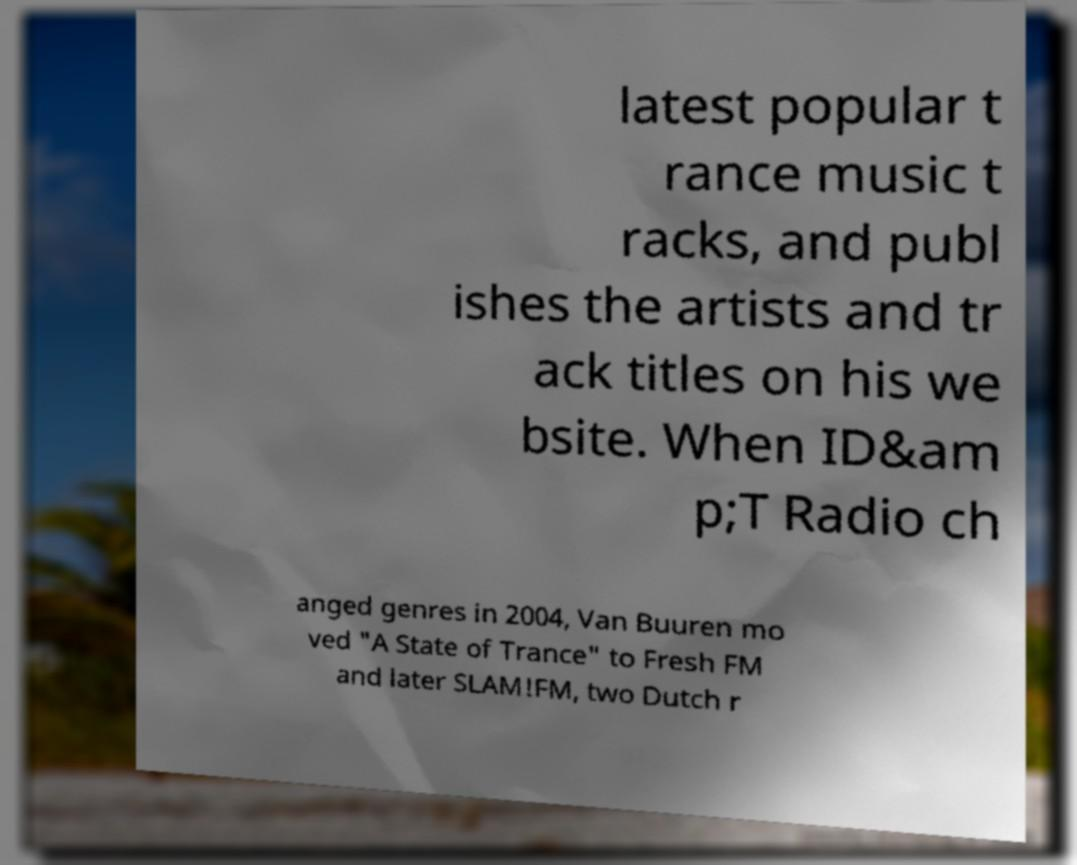Please identify and transcribe the text found in this image. latest popular t rance music t racks, and publ ishes the artists and tr ack titles on his we bsite. When ID&am p;T Radio ch anged genres in 2004, Van Buuren mo ved "A State of Trance" to Fresh FM and later SLAM!FM, two Dutch r 